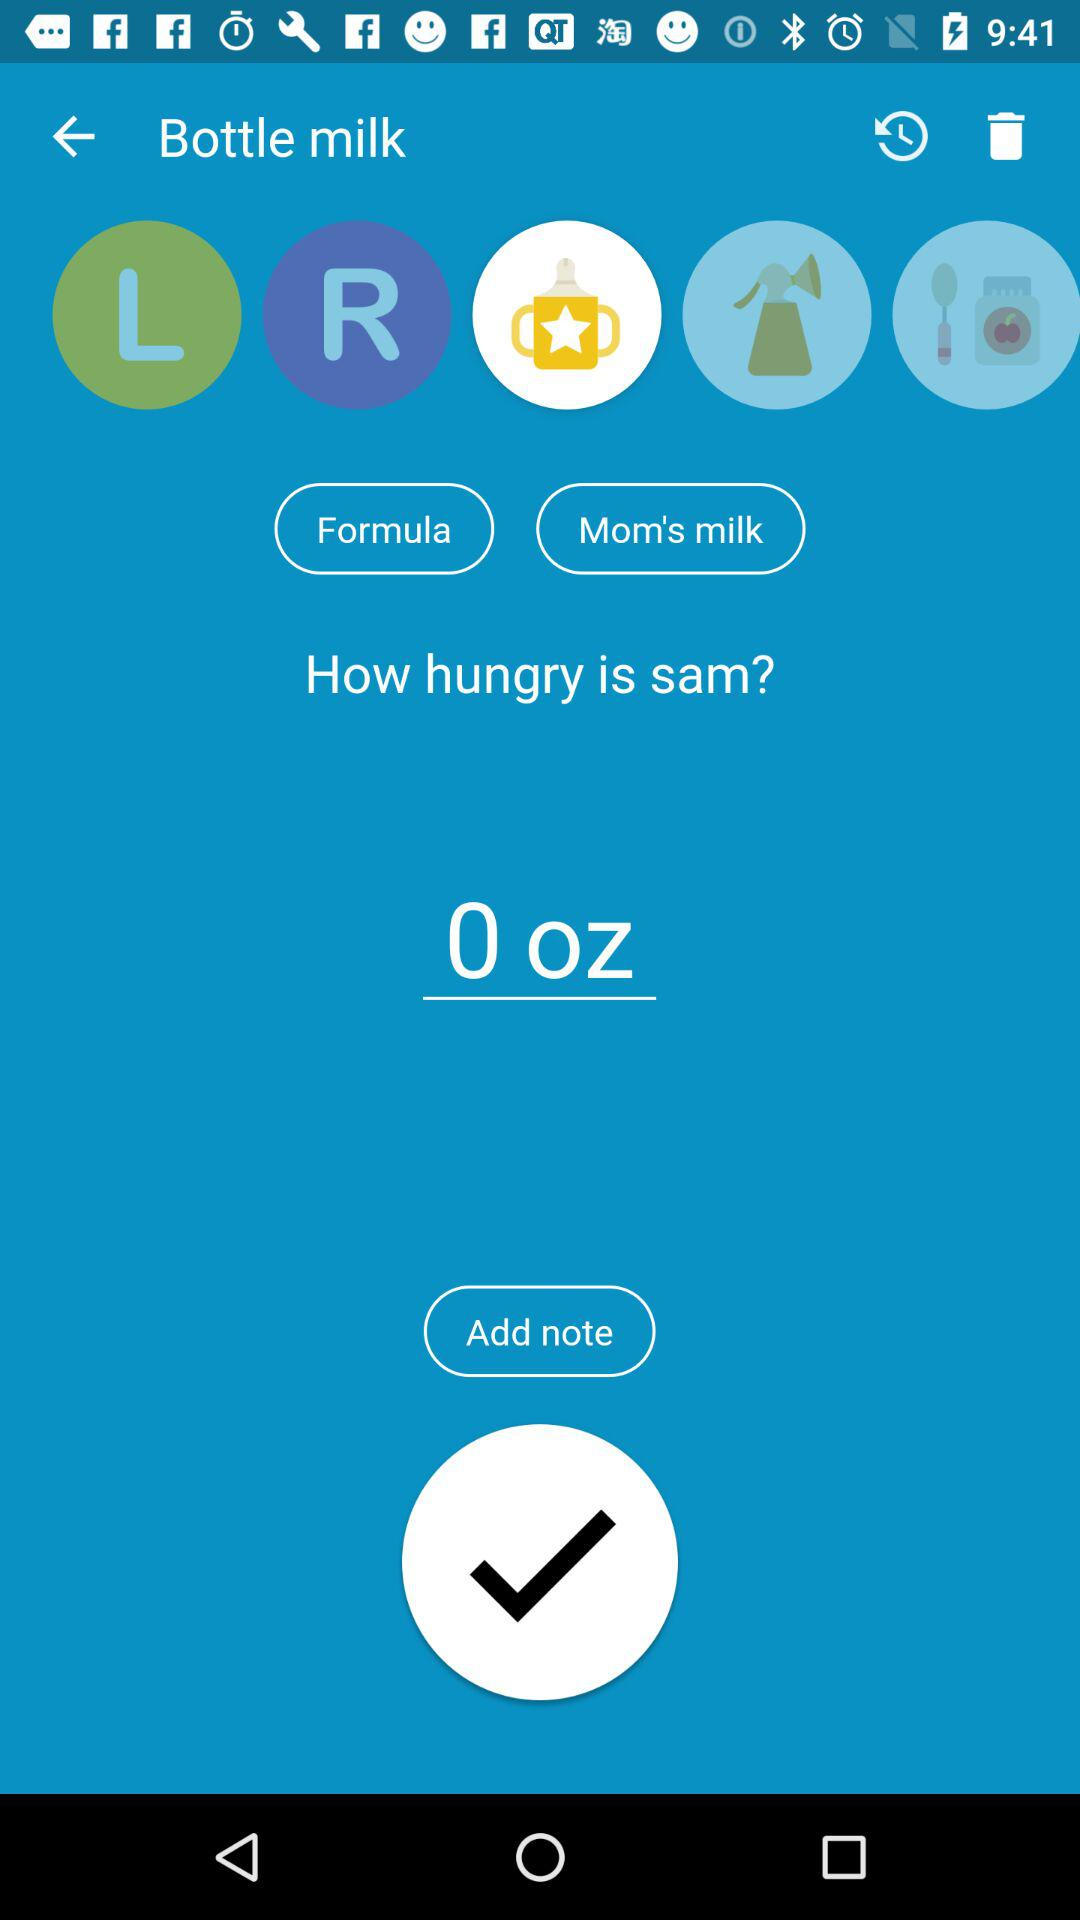What is the baby's name? The baby's name is Sam. 